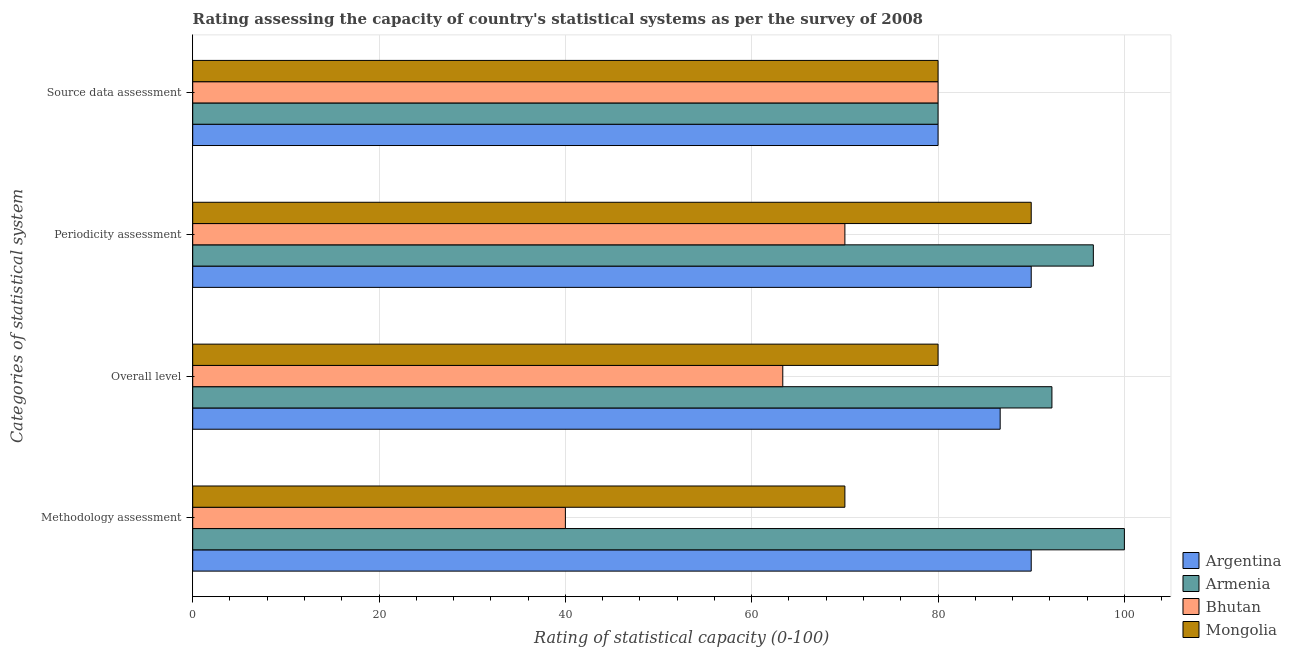How many different coloured bars are there?
Ensure brevity in your answer.  4. Are the number of bars per tick equal to the number of legend labels?
Make the answer very short. Yes. Are the number of bars on each tick of the Y-axis equal?
Your answer should be compact. Yes. How many bars are there on the 3rd tick from the bottom?
Keep it short and to the point. 4. What is the label of the 3rd group of bars from the top?
Offer a very short reply. Overall level. What is the overall level rating in Mongolia?
Ensure brevity in your answer.  80. Across all countries, what is the minimum source data assessment rating?
Ensure brevity in your answer.  80. In which country was the source data assessment rating maximum?
Keep it short and to the point. Argentina. What is the total periodicity assessment rating in the graph?
Ensure brevity in your answer.  346.67. What is the difference between the source data assessment rating in Mongolia and the overall level rating in Bhutan?
Your answer should be very brief. 16.67. What is the difference between the overall level rating and source data assessment rating in Argentina?
Make the answer very short. 6.67. Is the methodology assessment rating in Mongolia less than that in Armenia?
Your answer should be very brief. Yes. Is the difference between the periodicity assessment rating in Mongolia and Armenia greater than the difference between the methodology assessment rating in Mongolia and Armenia?
Provide a short and direct response. Yes. What is the difference between the highest and the second highest periodicity assessment rating?
Provide a succinct answer. 6.67. What is the difference between the highest and the lowest periodicity assessment rating?
Provide a short and direct response. 26.67. Is it the case that in every country, the sum of the source data assessment rating and methodology assessment rating is greater than the sum of periodicity assessment rating and overall level rating?
Your response must be concise. No. What does the 2nd bar from the bottom in Overall level represents?
Offer a very short reply. Armenia. How many bars are there?
Offer a terse response. 16. Are all the bars in the graph horizontal?
Give a very brief answer. Yes. How many countries are there in the graph?
Make the answer very short. 4. Does the graph contain any zero values?
Make the answer very short. No. Does the graph contain grids?
Your answer should be compact. Yes. What is the title of the graph?
Give a very brief answer. Rating assessing the capacity of country's statistical systems as per the survey of 2008 . Does "Belize" appear as one of the legend labels in the graph?
Give a very brief answer. No. What is the label or title of the X-axis?
Your answer should be very brief. Rating of statistical capacity (0-100). What is the label or title of the Y-axis?
Offer a very short reply. Categories of statistical system. What is the Rating of statistical capacity (0-100) of Argentina in Methodology assessment?
Provide a succinct answer. 90. What is the Rating of statistical capacity (0-100) of Mongolia in Methodology assessment?
Ensure brevity in your answer.  70. What is the Rating of statistical capacity (0-100) in Argentina in Overall level?
Offer a terse response. 86.67. What is the Rating of statistical capacity (0-100) in Armenia in Overall level?
Offer a terse response. 92.22. What is the Rating of statistical capacity (0-100) in Bhutan in Overall level?
Give a very brief answer. 63.33. What is the Rating of statistical capacity (0-100) in Mongolia in Overall level?
Offer a terse response. 80. What is the Rating of statistical capacity (0-100) of Armenia in Periodicity assessment?
Give a very brief answer. 96.67. What is the Rating of statistical capacity (0-100) in Bhutan in Periodicity assessment?
Ensure brevity in your answer.  70. What is the Rating of statistical capacity (0-100) of Mongolia in Periodicity assessment?
Make the answer very short. 90. Across all Categories of statistical system, what is the maximum Rating of statistical capacity (0-100) in Armenia?
Provide a short and direct response. 100. Across all Categories of statistical system, what is the maximum Rating of statistical capacity (0-100) of Bhutan?
Give a very brief answer. 80. Across all Categories of statistical system, what is the minimum Rating of statistical capacity (0-100) of Argentina?
Make the answer very short. 80. Across all Categories of statistical system, what is the minimum Rating of statistical capacity (0-100) of Armenia?
Make the answer very short. 80. Across all Categories of statistical system, what is the minimum Rating of statistical capacity (0-100) of Bhutan?
Ensure brevity in your answer.  40. Across all Categories of statistical system, what is the minimum Rating of statistical capacity (0-100) in Mongolia?
Provide a succinct answer. 70. What is the total Rating of statistical capacity (0-100) in Argentina in the graph?
Your answer should be very brief. 346.67. What is the total Rating of statistical capacity (0-100) of Armenia in the graph?
Make the answer very short. 368.89. What is the total Rating of statistical capacity (0-100) of Bhutan in the graph?
Offer a very short reply. 253.33. What is the total Rating of statistical capacity (0-100) of Mongolia in the graph?
Make the answer very short. 320. What is the difference between the Rating of statistical capacity (0-100) in Argentina in Methodology assessment and that in Overall level?
Offer a very short reply. 3.33. What is the difference between the Rating of statistical capacity (0-100) in Armenia in Methodology assessment and that in Overall level?
Ensure brevity in your answer.  7.78. What is the difference between the Rating of statistical capacity (0-100) of Bhutan in Methodology assessment and that in Overall level?
Offer a terse response. -23.33. What is the difference between the Rating of statistical capacity (0-100) in Mongolia in Methodology assessment and that in Overall level?
Your answer should be very brief. -10. What is the difference between the Rating of statistical capacity (0-100) of Armenia in Methodology assessment and that in Periodicity assessment?
Keep it short and to the point. 3.33. What is the difference between the Rating of statistical capacity (0-100) in Bhutan in Methodology assessment and that in Periodicity assessment?
Offer a terse response. -30. What is the difference between the Rating of statistical capacity (0-100) of Mongolia in Methodology assessment and that in Periodicity assessment?
Your response must be concise. -20. What is the difference between the Rating of statistical capacity (0-100) of Argentina in Methodology assessment and that in Source data assessment?
Your answer should be compact. 10. What is the difference between the Rating of statistical capacity (0-100) of Bhutan in Methodology assessment and that in Source data assessment?
Keep it short and to the point. -40. What is the difference between the Rating of statistical capacity (0-100) in Armenia in Overall level and that in Periodicity assessment?
Offer a very short reply. -4.44. What is the difference between the Rating of statistical capacity (0-100) of Bhutan in Overall level and that in Periodicity assessment?
Ensure brevity in your answer.  -6.67. What is the difference between the Rating of statistical capacity (0-100) of Mongolia in Overall level and that in Periodicity assessment?
Your response must be concise. -10. What is the difference between the Rating of statistical capacity (0-100) of Armenia in Overall level and that in Source data assessment?
Ensure brevity in your answer.  12.22. What is the difference between the Rating of statistical capacity (0-100) in Bhutan in Overall level and that in Source data assessment?
Make the answer very short. -16.67. What is the difference between the Rating of statistical capacity (0-100) in Argentina in Periodicity assessment and that in Source data assessment?
Give a very brief answer. 10. What is the difference between the Rating of statistical capacity (0-100) of Armenia in Periodicity assessment and that in Source data assessment?
Ensure brevity in your answer.  16.67. What is the difference between the Rating of statistical capacity (0-100) of Bhutan in Periodicity assessment and that in Source data assessment?
Provide a succinct answer. -10. What is the difference between the Rating of statistical capacity (0-100) in Argentina in Methodology assessment and the Rating of statistical capacity (0-100) in Armenia in Overall level?
Your response must be concise. -2.22. What is the difference between the Rating of statistical capacity (0-100) in Argentina in Methodology assessment and the Rating of statistical capacity (0-100) in Bhutan in Overall level?
Offer a very short reply. 26.67. What is the difference between the Rating of statistical capacity (0-100) in Armenia in Methodology assessment and the Rating of statistical capacity (0-100) in Bhutan in Overall level?
Make the answer very short. 36.67. What is the difference between the Rating of statistical capacity (0-100) in Armenia in Methodology assessment and the Rating of statistical capacity (0-100) in Mongolia in Overall level?
Keep it short and to the point. 20. What is the difference between the Rating of statistical capacity (0-100) in Bhutan in Methodology assessment and the Rating of statistical capacity (0-100) in Mongolia in Overall level?
Offer a terse response. -40. What is the difference between the Rating of statistical capacity (0-100) of Argentina in Methodology assessment and the Rating of statistical capacity (0-100) of Armenia in Periodicity assessment?
Your response must be concise. -6.67. What is the difference between the Rating of statistical capacity (0-100) of Argentina in Methodology assessment and the Rating of statistical capacity (0-100) of Bhutan in Periodicity assessment?
Provide a succinct answer. 20. What is the difference between the Rating of statistical capacity (0-100) of Armenia in Methodology assessment and the Rating of statistical capacity (0-100) of Mongolia in Periodicity assessment?
Offer a very short reply. 10. What is the difference between the Rating of statistical capacity (0-100) in Armenia in Methodology assessment and the Rating of statistical capacity (0-100) in Bhutan in Source data assessment?
Provide a short and direct response. 20. What is the difference between the Rating of statistical capacity (0-100) in Armenia in Methodology assessment and the Rating of statistical capacity (0-100) in Mongolia in Source data assessment?
Offer a terse response. 20. What is the difference between the Rating of statistical capacity (0-100) in Bhutan in Methodology assessment and the Rating of statistical capacity (0-100) in Mongolia in Source data assessment?
Give a very brief answer. -40. What is the difference between the Rating of statistical capacity (0-100) of Argentina in Overall level and the Rating of statistical capacity (0-100) of Armenia in Periodicity assessment?
Ensure brevity in your answer.  -10. What is the difference between the Rating of statistical capacity (0-100) in Argentina in Overall level and the Rating of statistical capacity (0-100) in Bhutan in Periodicity assessment?
Your answer should be compact. 16.67. What is the difference between the Rating of statistical capacity (0-100) of Argentina in Overall level and the Rating of statistical capacity (0-100) of Mongolia in Periodicity assessment?
Your response must be concise. -3.33. What is the difference between the Rating of statistical capacity (0-100) of Armenia in Overall level and the Rating of statistical capacity (0-100) of Bhutan in Periodicity assessment?
Give a very brief answer. 22.22. What is the difference between the Rating of statistical capacity (0-100) in Armenia in Overall level and the Rating of statistical capacity (0-100) in Mongolia in Periodicity assessment?
Give a very brief answer. 2.22. What is the difference between the Rating of statistical capacity (0-100) of Bhutan in Overall level and the Rating of statistical capacity (0-100) of Mongolia in Periodicity assessment?
Your response must be concise. -26.67. What is the difference between the Rating of statistical capacity (0-100) in Argentina in Overall level and the Rating of statistical capacity (0-100) in Armenia in Source data assessment?
Provide a short and direct response. 6.67. What is the difference between the Rating of statistical capacity (0-100) of Argentina in Overall level and the Rating of statistical capacity (0-100) of Bhutan in Source data assessment?
Provide a short and direct response. 6.67. What is the difference between the Rating of statistical capacity (0-100) in Argentina in Overall level and the Rating of statistical capacity (0-100) in Mongolia in Source data assessment?
Offer a terse response. 6.67. What is the difference between the Rating of statistical capacity (0-100) of Armenia in Overall level and the Rating of statistical capacity (0-100) of Bhutan in Source data assessment?
Make the answer very short. 12.22. What is the difference between the Rating of statistical capacity (0-100) of Armenia in Overall level and the Rating of statistical capacity (0-100) of Mongolia in Source data assessment?
Keep it short and to the point. 12.22. What is the difference between the Rating of statistical capacity (0-100) of Bhutan in Overall level and the Rating of statistical capacity (0-100) of Mongolia in Source data assessment?
Provide a succinct answer. -16.67. What is the difference between the Rating of statistical capacity (0-100) in Argentina in Periodicity assessment and the Rating of statistical capacity (0-100) in Armenia in Source data assessment?
Offer a very short reply. 10. What is the difference between the Rating of statistical capacity (0-100) of Argentina in Periodicity assessment and the Rating of statistical capacity (0-100) of Bhutan in Source data assessment?
Give a very brief answer. 10. What is the difference between the Rating of statistical capacity (0-100) in Argentina in Periodicity assessment and the Rating of statistical capacity (0-100) in Mongolia in Source data assessment?
Offer a terse response. 10. What is the difference between the Rating of statistical capacity (0-100) of Armenia in Periodicity assessment and the Rating of statistical capacity (0-100) of Bhutan in Source data assessment?
Ensure brevity in your answer.  16.67. What is the difference between the Rating of statistical capacity (0-100) of Armenia in Periodicity assessment and the Rating of statistical capacity (0-100) of Mongolia in Source data assessment?
Your response must be concise. 16.67. What is the difference between the Rating of statistical capacity (0-100) in Bhutan in Periodicity assessment and the Rating of statistical capacity (0-100) in Mongolia in Source data assessment?
Your answer should be very brief. -10. What is the average Rating of statistical capacity (0-100) in Argentina per Categories of statistical system?
Make the answer very short. 86.67. What is the average Rating of statistical capacity (0-100) in Armenia per Categories of statistical system?
Provide a succinct answer. 92.22. What is the average Rating of statistical capacity (0-100) in Bhutan per Categories of statistical system?
Your response must be concise. 63.33. What is the difference between the Rating of statistical capacity (0-100) of Argentina and Rating of statistical capacity (0-100) of Bhutan in Methodology assessment?
Provide a succinct answer. 50. What is the difference between the Rating of statistical capacity (0-100) in Argentina and Rating of statistical capacity (0-100) in Mongolia in Methodology assessment?
Your answer should be compact. 20. What is the difference between the Rating of statistical capacity (0-100) in Armenia and Rating of statistical capacity (0-100) in Bhutan in Methodology assessment?
Provide a succinct answer. 60. What is the difference between the Rating of statistical capacity (0-100) of Armenia and Rating of statistical capacity (0-100) of Mongolia in Methodology assessment?
Give a very brief answer. 30. What is the difference between the Rating of statistical capacity (0-100) of Bhutan and Rating of statistical capacity (0-100) of Mongolia in Methodology assessment?
Provide a succinct answer. -30. What is the difference between the Rating of statistical capacity (0-100) of Argentina and Rating of statistical capacity (0-100) of Armenia in Overall level?
Keep it short and to the point. -5.56. What is the difference between the Rating of statistical capacity (0-100) of Argentina and Rating of statistical capacity (0-100) of Bhutan in Overall level?
Your answer should be compact. 23.33. What is the difference between the Rating of statistical capacity (0-100) in Armenia and Rating of statistical capacity (0-100) in Bhutan in Overall level?
Provide a succinct answer. 28.89. What is the difference between the Rating of statistical capacity (0-100) in Armenia and Rating of statistical capacity (0-100) in Mongolia in Overall level?
Keep it short and to the point. 12.22. What is the difference between the Rating of statistical capacity (0-100) in Bhutan and Rating of statistical capacity (0-100) in Mongolia in Overall level?
Offer a terse response. -16.67. What is the difference between the Rating of statistical capacity (0-100) in Argentina and Rating of statistical capacity (0-100) in Armenia in Periodicity assessment?
Make the answer very short. -6.67. What is the difference between the Rating of statistical capacity (0-100) in Argentina and Rating of statistical capacity (0-100) in Mongolia in Periodicity assessment?
Offer a very short reply. 0. What is the difference between the Rating of statistical capacity (0-100) in Armenia and Rating of statistical capacity (0-100) in Bhutan in Periodicity assessment?
Your answer should be compact. 26.67. What is the difference between the Rating of statistical capacity (0-100) of Bhutan and Rating of statistical capacity (0-100) of Mongolia in Periodicity assessment?
Your answer should be compact. -20. What is the difference between the Rating of statistical capacity (0-100) of Armenia and Rating of statistical capacity (0-100) of Bhutan in Source data assessment?
Provide a short and direct response. 0. What is the difference between the Rating of statistical capacity (0-100) of Armenia and Rating of statistical capacity (0-100) of Mongolia in Source data assessment?
Offer a terse response. 0. What is the difference between the Rating of statistical capacity (0-100) of Bhutan and Rating of statistical capacity (0-100) of Mongolia in Source data assessment?
Your response must be concise. 0. What is the ratio of the Rating of statistical capacity (0-100) in Armenia in Methodology assessment to that in Overall level?
Offer a very short reply. 1.08. What is the ratio of the Rating of statistical capacity (0-100) of Bhutan in Methodology assessment to that in Overall level?
Your answer should be very brief. 0.63. What is the ratio of the Rating of statistical capacity (0-100) of Mongolia in Methodology assessment to that in Overall level?
Your response must be concise. 0.88. What is the ratio of the Rating of statistical capacity (0-100) of Argentina in Methodology assessment to that in Periodicity assessment?
Give a very brief answer. 1. What is the ratio of the Rating of statistical capacity (0-100) in Armenia in Methodology assessment to that in Periodicity assessment?
Keep it short and to the point. 1.03. What is the ratio of the Rating of statistical capacity (0-100) in Argentina in Methodology assessment to that in Source data assessment?
Keep it short and to the point. 1.12. What is the ratio of the Rating of statistical capacity (0-100) in Armenia in Methodology assessment to that in Source data assessment?
Make the answer very short. 1.25. What is the ratio of the Rating of statistical capacity (0-100) in Bhutan in Methodology assessment to that in Source data assessment?
Offer a very short reply. 0.5. What is the ratio of the Rating of statistical capacity (0-100) in Mongolia in Methodology assessment to that in Source data assessment?
Offer a very short reply. 0.88. What is the ratio of the Rating of statistical capacity (0-100) of Argentina in Overall level to that in Periodicity assessment?
Offer a very short reply. 0.96. What is the ratio of the Rating of statistical capacity (0-100) of Armenia in Overall level to that in Periodicity assessment?
Keep it short and to the point. 0.95. What is the ratio of the Rating of statistical capacity (0-100) in Bhutan in Overall level to that in Periodicity assessment?
Ensure brevity in your answer.  0.9. What is the ratio of the Rating of statistical capacity (0-100) of Argentina in Overall level to that in Source data assessment?
Make the answer very short. 1.08. What is the ratio of the Rating of statistical capacity (0-100) in Armenia in Overall level to that in Source data assessment?
Ensure brevity in your answer.  1.15. What is the ratio of the Rating of statistical capacity (0-100) in Bhutan in Overall level to that in Source data assessment?
Your answer should be compact. 0.79. What is the ratio of the Rating of statistical capacity (0-100) of Argentina in Periodicity assessment to that in Source data assessment?
Make the answer very short. 1.12. What is the ratio of the Rating of statistical capacity (0-100) of Armenia in Periodicity assessment to that in Source data assessment?
Your answer should be very brief. 1.21. What is the ratio of the Rating of statistical capacity (0-100) of Mongolia in Periodicity assessment to that in Source data assessment?
Give a very brief answer. 1.12. What is the difference between the highest and the second highest Rating of statistical capacity (0-100) of Mongolia?
Keep it short and to the point. 10. What is the difference between the highest and the lowest Rating of statistical capacity (0-100) of Argentina?
Ensure brevity in your answer.  10. What is the difference between the highest and the lowest Rating of statistical capacity (0-100) of Armenia?
Provide a succinct answer. 20. What is the difference between the highest and the lowest Rating of statistical capacity (0-100) of Mongolia?
Give a very brief answer. 20. 